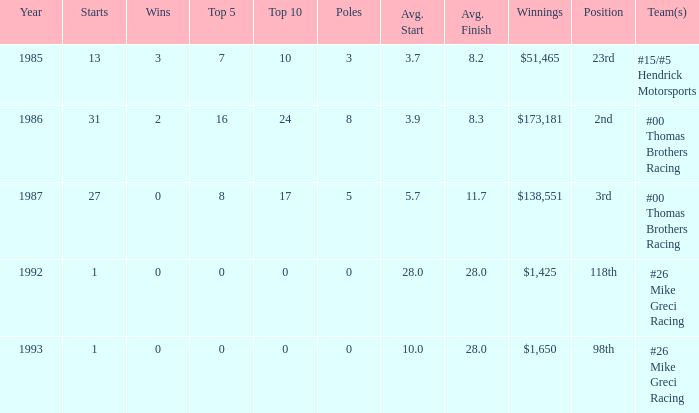3? #00 Thomas Brothers Racing. 